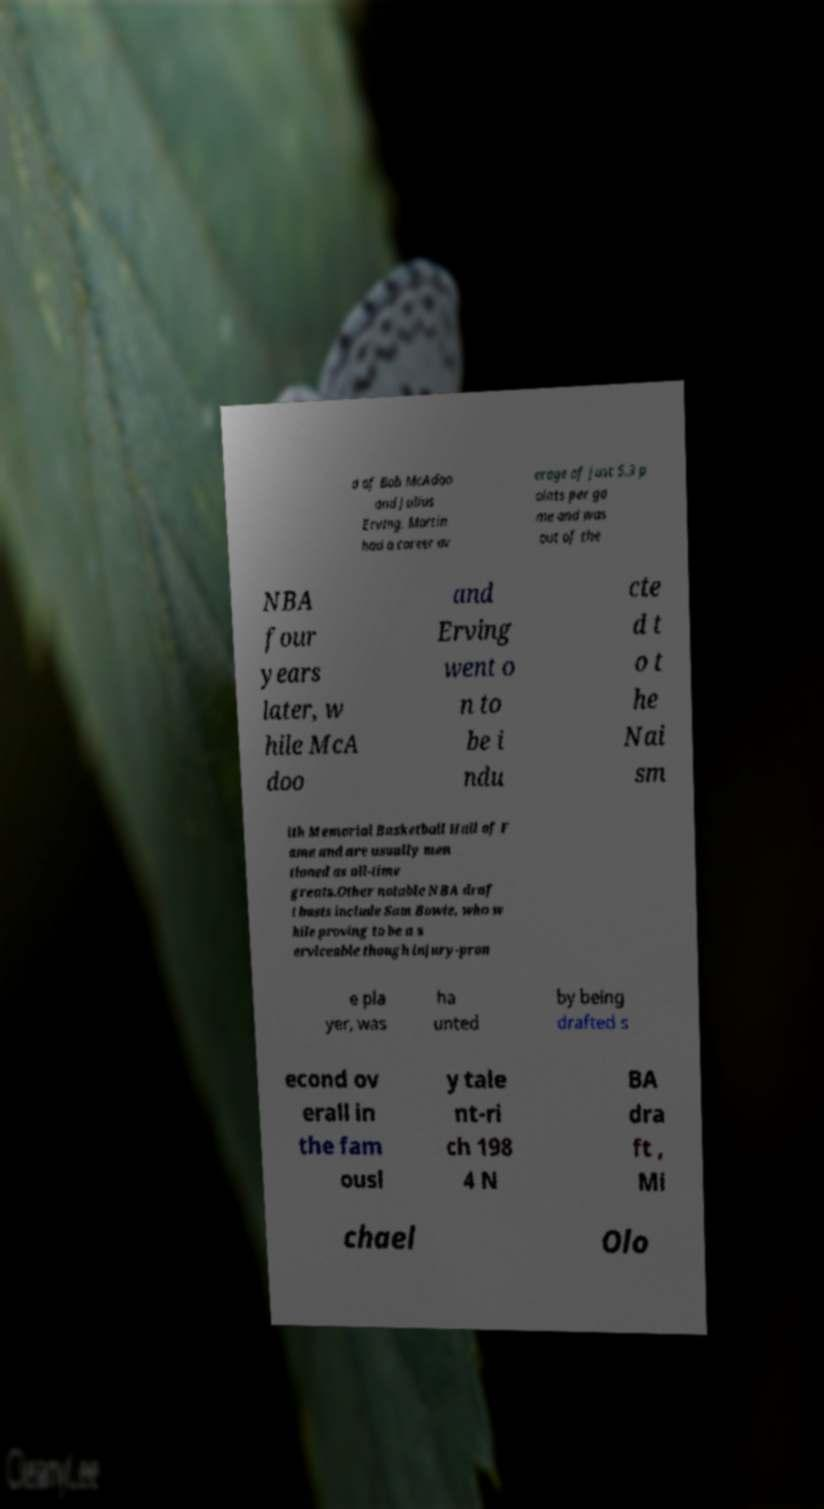Could you assist in decoding the text presented in this image and type it out clearly? d of Bob McAdoo and Julius Erving. Martin had a career av erage of just 5.3 p oints per ga me and was out of the NBA four years later, w hile McA doo and Erving went o n to be i ndu cte d t o t he Nai sm ith Memorial Basketball Hall of F ame and are usually men tioned as all-time greats.Other notable NBA draf t busts include Sam Bowie, who w hile proving to be a s erviceable though injury-pron e pla yer, was ha unted by being drafted s econd ov erall in the fam ousl y tale nt-ri ch 198 4 N BA dra ft , Mi chael Olo 